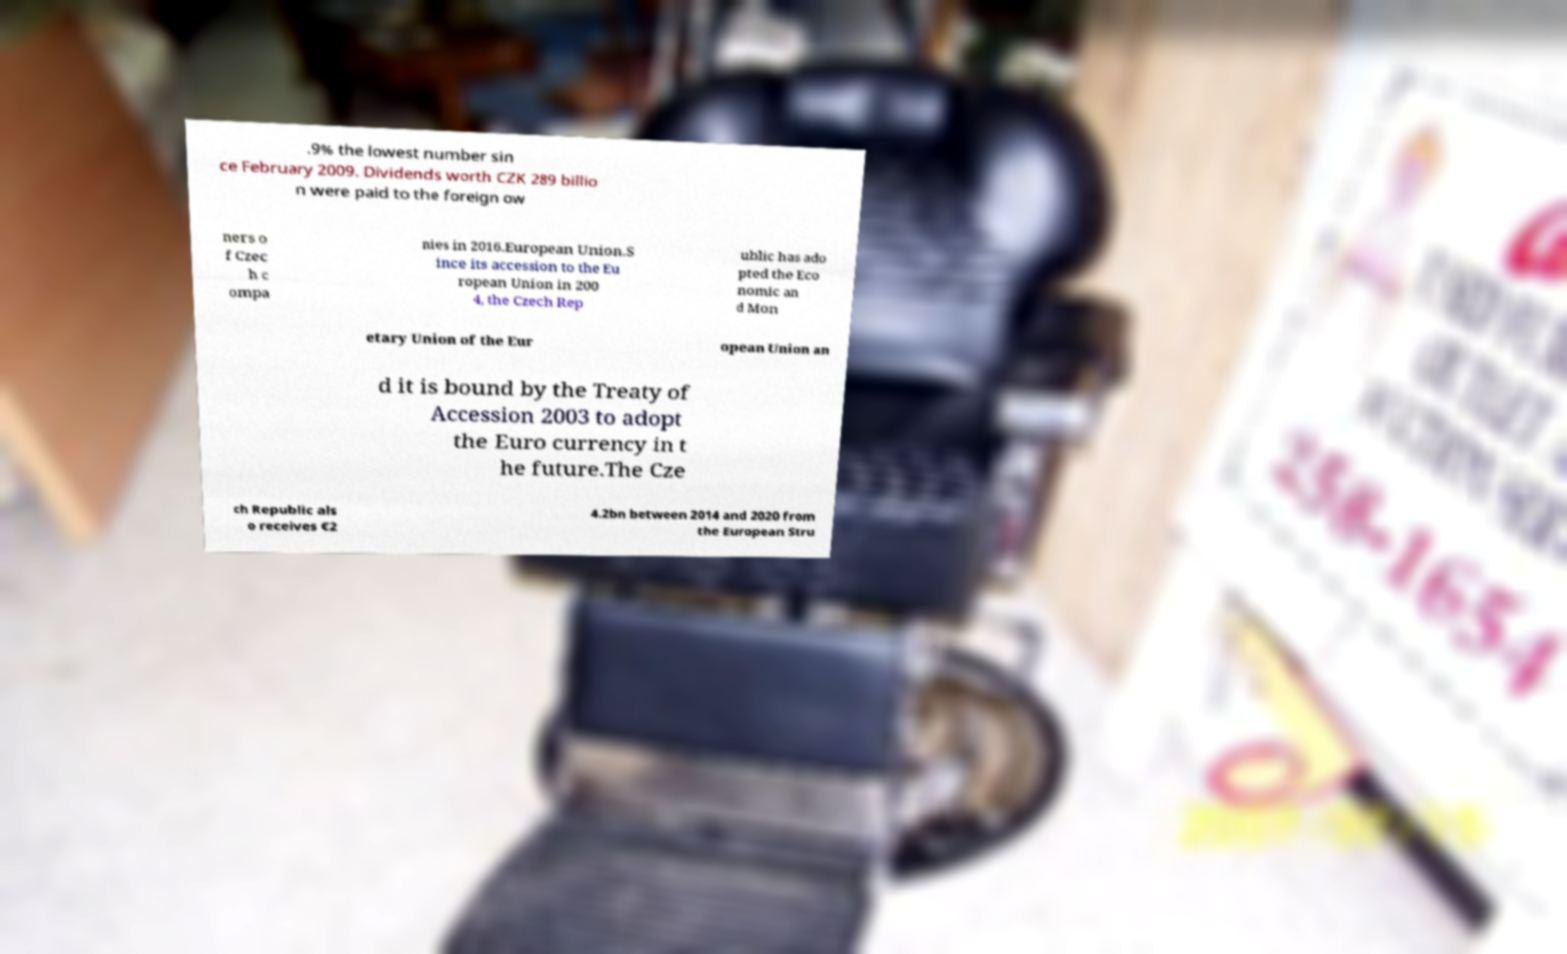Can you read and provide the text displayed in the image?This photo seems to have some interesting text. Can you extract and type it out for me? .9% the lowest number sin ce February 2009. Dividends worth CZK 289 billio n were paid to the foreign ow ners o f Czec h c ompa nies in 2016.European Union.S ince its accession to the Eu ropean Union in 200 4, the Czech Rep ublic has ado pted the Eco nomic an d Mon etary Union of the Eur opean Union an d it is bound by the Treaty of Accession 2003 to adopt the Euro currency in t he future.The Cze ch Republic als o receives €2 4.2bn between 2014 and 2020 from the European Stru 